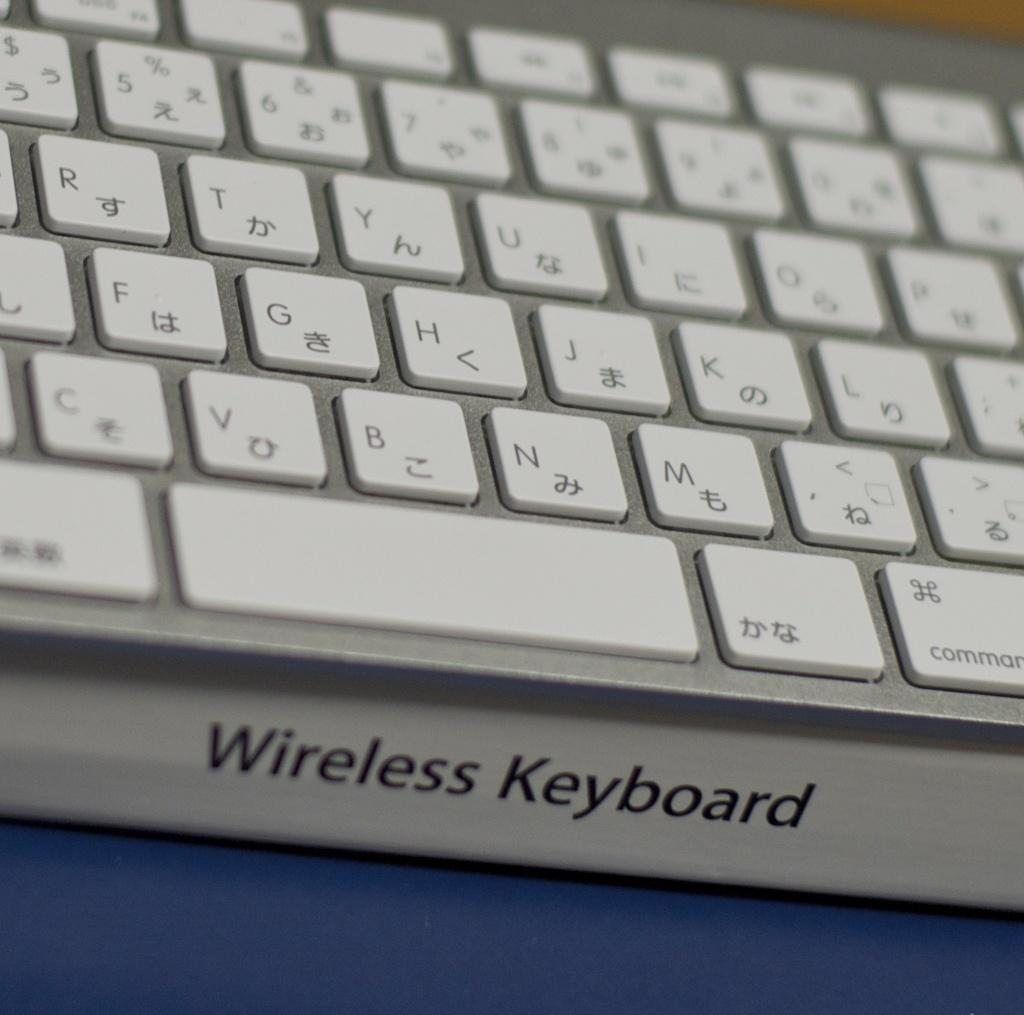What type of device is visible in the image? There is a keyboard in the image. What type of connection does the keyboard have? The keyboard is labeled as a 'wireless keyboard'. What is the color of the keyboard? The keyboard is silver in color. What is the color of the table the keyboard is placed on? There is a blue table in the image. How many fingers are shown on the keyboard in the image? There is no indication of fingers on the keyboard in the image. 